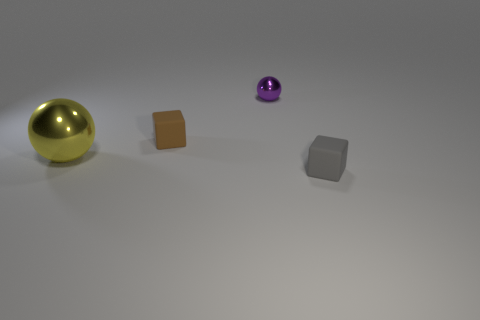Do the yellow metallic thing and the brown object have the same size?
Keep it short and to the point. No. There is a brown cube; what number of objects are to the right of it?
Provide a short and direct response. 2. What number of things are either big balls that are left of the tiny gray cube or yellow balls?
Offer a terse response. 1. Is the number of big metallic things to the left of the purple thing greater than the number of cubes that are behind the brown matte cube?
Provide a succinct answer. Yes. Does the purple object have the same size as the metallic sphere in front of the tiny ball?
Offer a very short reply. No. How many spheres are small purple shiny things or green things?
Provide a short and direct response. 1. There is a thing that is made of the same material as the big ball; what size is it?
Your answer should be very brief. Small. Is the size of the rubber cube left of the gray thing the same as the matte object in front of the big object?
Keep it short and to the point. Yes. What number of objects are either blocks or large yellow spheres?
Make the answer very short. 3. What shape is the tiny gray thing?
Ensure brevity in your answer.  Cube. 